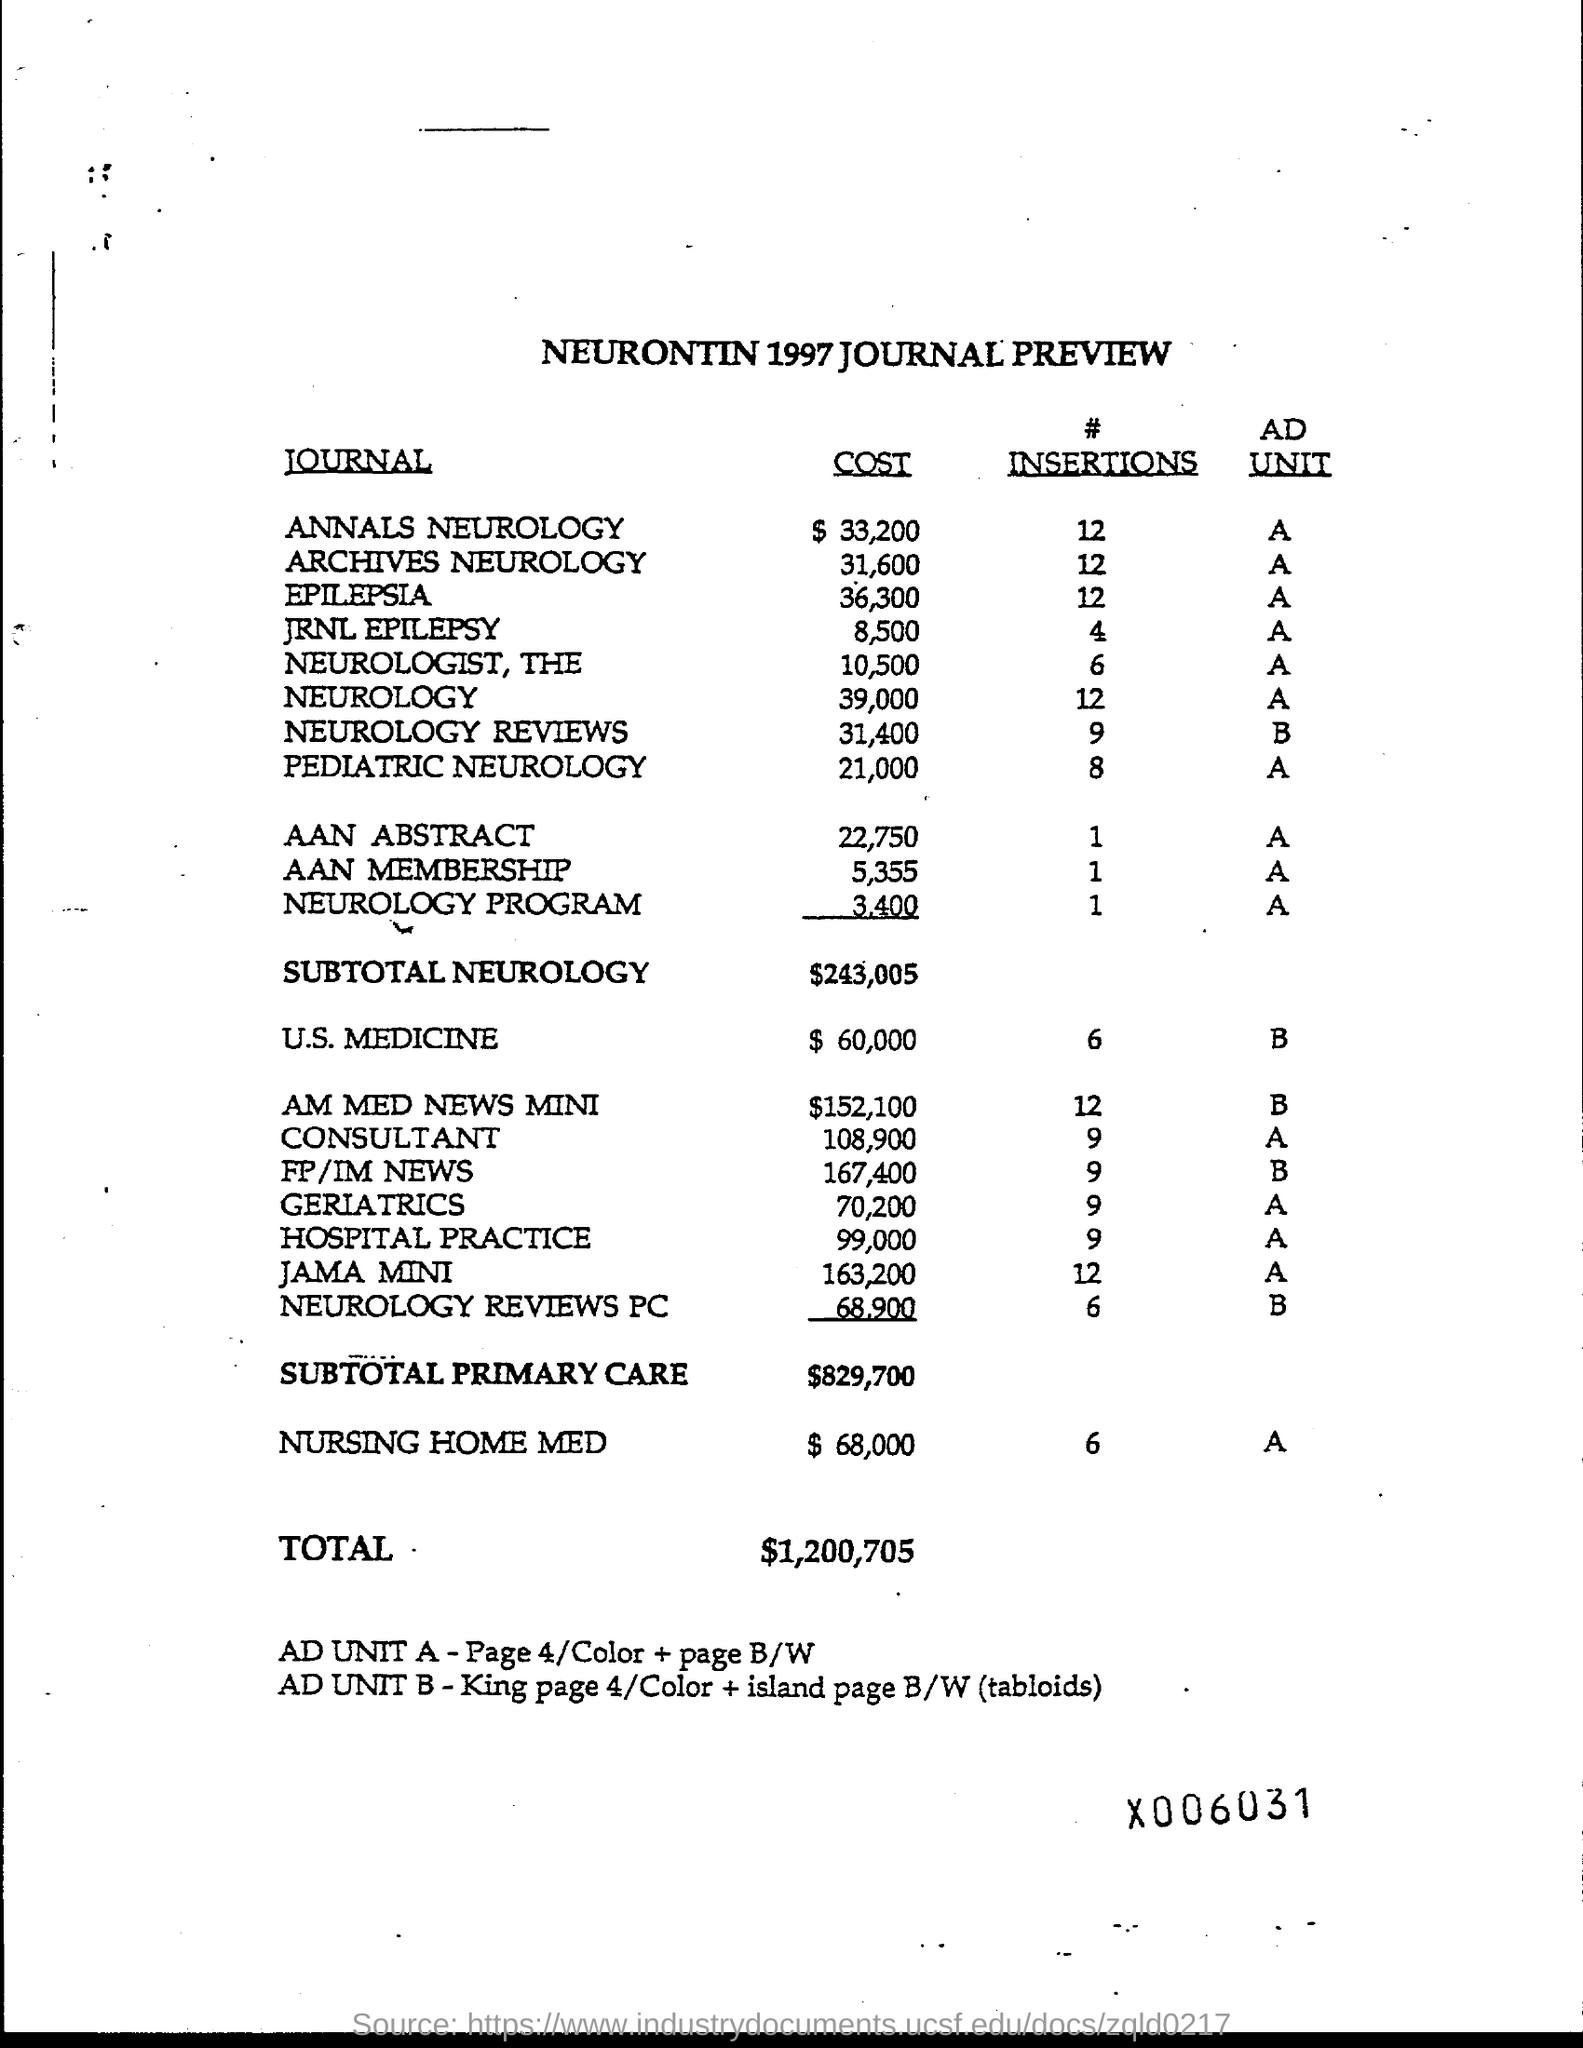What is the total amount ?
Keep it short and to the point. $1,200,705. What is the cost of annals neurology ?
Offer a terse response. $33,200. What is the cost of archives neurology ?
Ensure brevity in your answer.  $31,600. What is the cost of epilepsia ?
Provide a succinct answer. 36,300. What is the cost of jrnl epilepsy ?
Provide a short and direct response. $8,500. What is the cost of pediatric neurology ?
Your response must be concise. 21,000. What is the cost of aan abstract ?
Give a very brief answer. 22,750. What is the cost of aan membership?
Provide a succinct answer. 5,355. What is the cost of neurology program?
Offer a very short reply. 3,400. What is the cost of u.s. medicine ?
Keep it short and to the point. $60,000. 